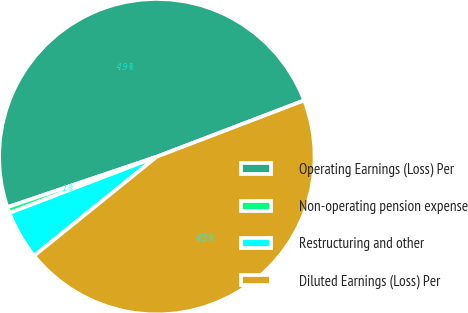<chart> <loc_0><loc_0><loc_500><loc_500><pie_chart><fcel>Operating Earnings (Loss) Per<fcel>Non-operating pension expense<fcel>Restructuring and other<fcel>Diluted Earnings (Loss) Per<nl><fcel>49.38%<fcel>0.62%<fcel>5.0%<fcel>45.0%<nl></chart> 